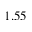<formula> <loc_0><loc_0><loc_500><loc_500>1 . 5 5</formula> 